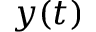<formula> <loc_0><loc_0><loc_500><loc_500>y ( t )</formula> 